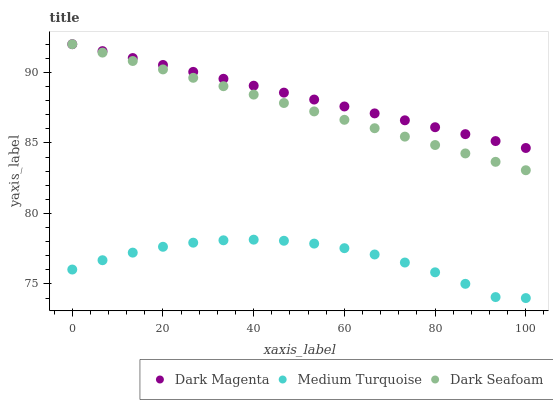Does Medium Turquoise have the minimum area under the curve?
Answer yes or no. Yes. Does Dark Magenta have the maximum area under the curve?
Answer yes or no. Yes. Does Dark Magenta have the minimum area under the curve?
Answer yes or no. No. Does Medium Turquoise have the maximum area under the curve?
Answer yes or no. No. Is Dark Seafoam the smoothest?
Answer yes or no. Yes. Is Medium Turquoise the roughest?
Answer yes or no. Yes. Is Dark Magenta the smoothest?
Answer yes or no. No. Is Dark Magenta the roughest?
Answer yes or no. No. Does Medium Turquoise have the lowest value?
Answer yes or no. Yes. Does Dark Magenta have the lowest value?
Answer yes or no. No. Does Dark Magenta have the highest value?
Answer yes or no. Yes. Does Medium Turquoise have the highest value?
Answer yes or no. No. Is Medium Turquoise less than Dark Magenta?
Answer yes or no. Yes. Is Dark Seafoam greater than Medium Turquoise?
Answer yes or no. Yes. Does Dark Seafoam intersect Dark Magenta?
Answer yes or no. Yes. Is Dark Seafoam less than Dark Magenta?
Answer yes or no. No. Is Dark Seafoam greater than Dark Magenta?
Answer yes or no. No. Does Medium Turquoise intersect Dark Magenta?
Answer yes or no. No. 